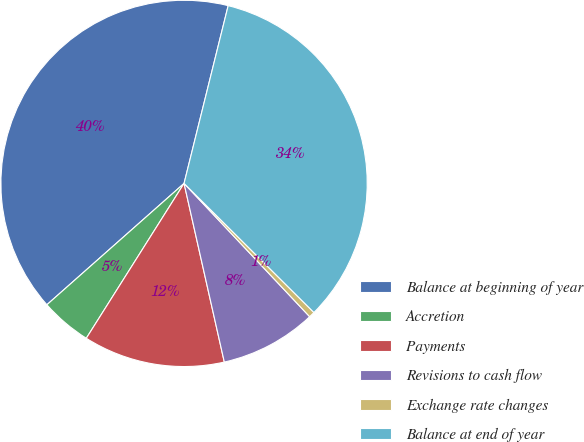Convert chart. <chart><loc_0><loc_0><loc_500><loc_500><pie_chart><fcel>Balance at beginning of year<fcel>Accretion<fcel>Payments<fcel>Revisions to cash flow<fcel>Exchange rate changes<fcel>Balance at end of year<nl><fcel>40.4%<fcel>4.51%<fcel>12.49%<fcel>8.5%<fcel>0.52%<fcel>33.58%<nl></chart> 